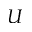Convert formula to latex. <formula><loc_0><loc_0><loc_500><loc_500>U</formula> 